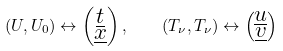Convert formula to latex. <formula><loc_0><loc_0><loc_500><loc_500>( U , U _ { 0 } ) \leftrightarrow \left ( \substack { \underline { t } \\ \underline { x } } \right ) , \quad ( T _ { \nu } , T _ { \nu } ) \leftrightarrow \left ( \substack { \underline { u } \\ \underline { v } } \right )</formula> 